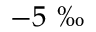Convert formula to latex. <formula><loc_0><loc_0><loc_500><loc_500>- 5 \text  perthousand</formula> 